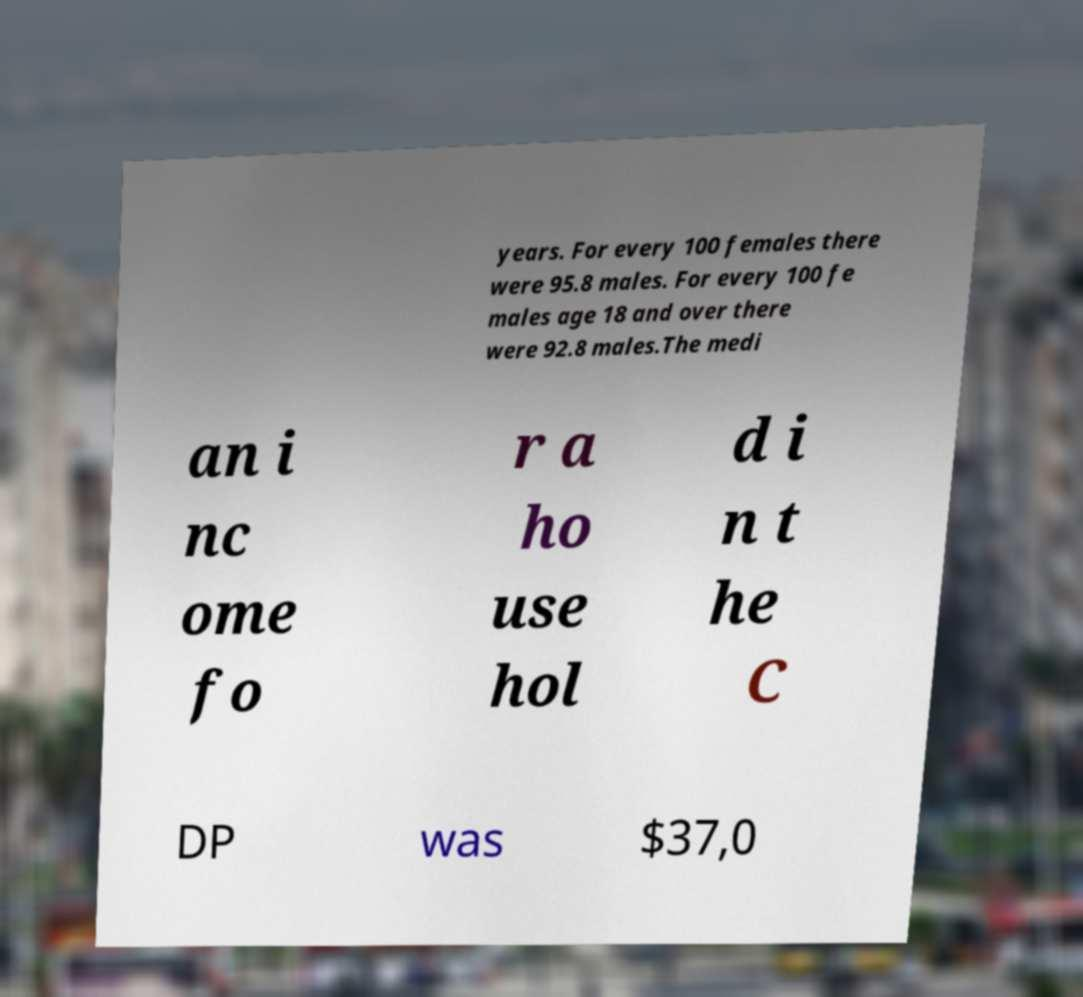Can you accurately transcribe the text from the provided image for me? years. For every 100 females there were 95.8 males. For every 100 fe males age 18 and over there were 92.8 males.The medi an i nc ome fo r a ho use hol d i n t he C DP was $37,0 